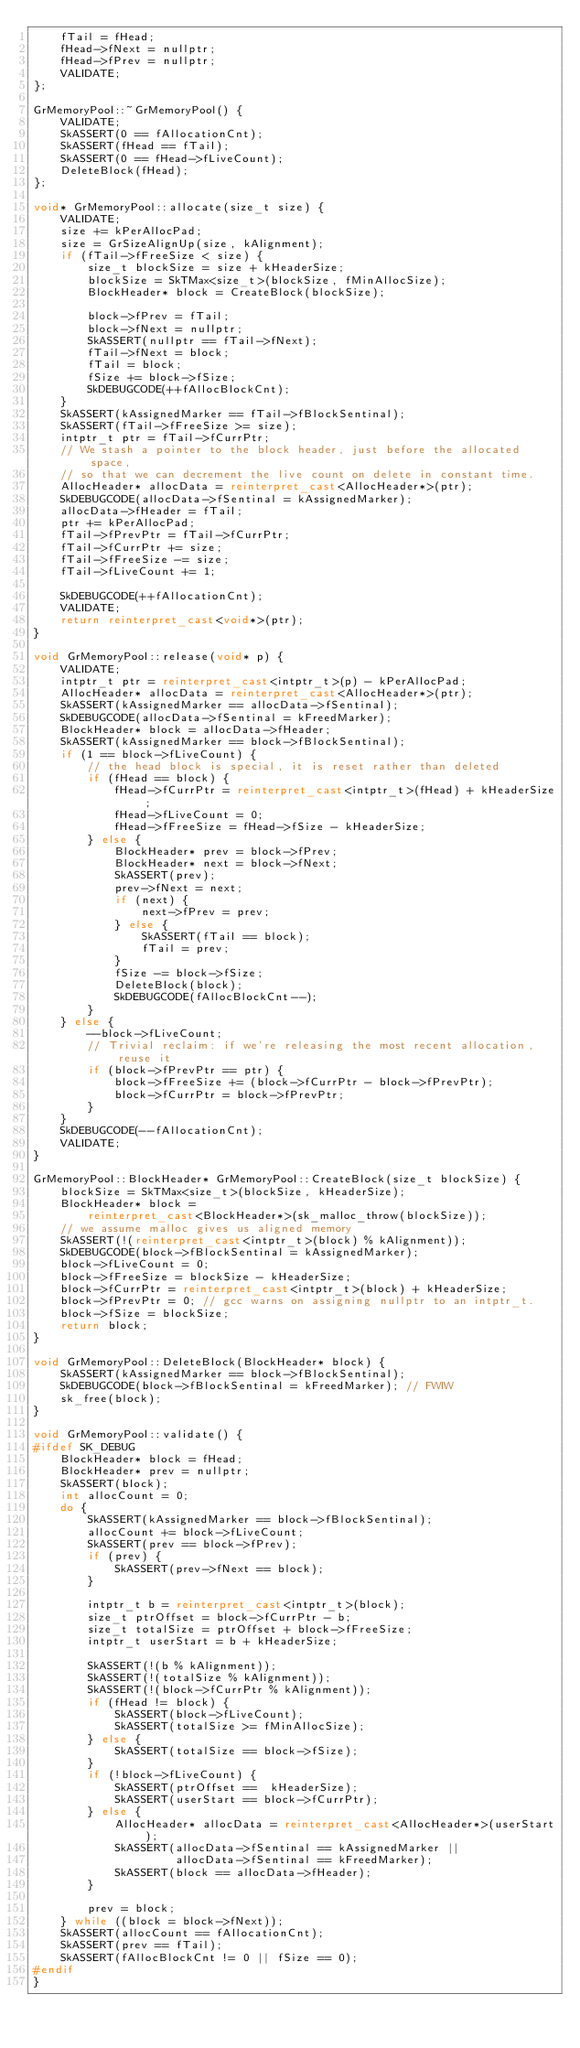Convert code to text. <code><loc_0><loc_0><loc_500><loc_500><_C++_>    fTail = fHead;
    fHead->fNext = nullptr;
    fHead->fPrev = nullptr;
    VALIDATE;
};

GrMemoryPool::~GrMemoryPool() {
    VALIDATE;
    SkASSERT(0 == fAllocationCnt);
    SkASSERT(fHead == fTail);
    SkASSERT(0 == fHead->fLiveCount);
    DeleteBlock(fHead);
};

void* GrMemoryPool::allocate(size_t size) {
    VALIDATE;
    size += kPerAllocPad;
    size = GrSizeAlignUp(size, kAlignment);
    if (fTail->fFreeSize < size) {
        size_t blockSize = size + kHeaderSize;
        blockSize = SkTMax<size_t>(blockSize, fMinAllocSize);
        BlockHeader* block = CreateBlock(blockSize);

        block->fPrev = fTail;
        block->fNext = nullptr;
        SkASSERT(nullptr == fTail->fNext);
        fTail->fNext = block;
        fTail = block;
        fSize += block->fSize;
        SkDEBUGCODE(++fAllocBlockCnt);
    }
    SkASSERT(kAssignedMarker == fTail->fBlockSentinal);
    SkASSERT(fTail->fFreeSize >= size);
    intptr_t ptr = fTail->fCurrPtr;
    // We stash a pointer to the block header, just before the allocated space,
    // so that we can decrement the live count on delete in constant time.
    AllocHeader* allocData = reinterpret_cast<AllocHeader*>(ptr);
    SkDEBUGCODE(allocData->fSentinal = kAssignedMarker);
    allocData->fHeader = fTail;
    ptr += kPerAllocPad;
    fTail->fPrevPtr = fTail->fCurrPtr;
    fTail->fCurrPtr += size;
    fTail->fFreeSize -= size;
    fTail->fLiveCount += 1;

    SkDEBUGCODE(++fAllocationCnt);
    VALIDATE;
    return reinterpret_cast<void*>(ptr);
}

void GrMemoryPool::release(void* p) {
    VALIDATE;
    intptr_t ptr = reinterpret_cast<intptr_t>(p) - kPerAllocPad;
    AllocHeader* allocData = reinterpret_cast<AllocHeader*>(ptr);
    SkASSERT(kAssignedMarker == allocData->fSentinal);
    SkDEBUGCODE(allocData->fSentinal = kFreedMarker);
    BlockHeader* block = allocData->fHeader;
    SkASSERT(kAssignedMarker == block->fBlockSentinal);
    if (1 == block->fLiveCount) {
        // the head block is special, it is reset rather than deleted
        if (fHead == block) {
            fHead->fCurrPtr = reinterpret_cast<intptr_t>(fHead) + kHeaderSize;
            fHead->fLiveCount = 0;
            fHead->fFreeSize = fHead->fSize - kHeaderSize;
        } else {
            BlockHeader* prev = block->fPrev;
            BlockHeader* next = block->fNext;
            SkASSERT(prev);
            prev->fNext = next;
            if (next) {
                next->fPrev = prev;
            } else {
                SkASSERT(fTail == block);
                fTail = prev;
            }
            fSize -= block->fSize;
            DeleteBlock(block);
            SkDEBUGCODE(fAllocBlockCnt--);
        }
    } else {
        --block->fLiveCount;
        // Trivial reclaim: if we're releasing the most recent allocation, reuse it
        if (block->fPrevPtr == ptr) {
            block->fFreeSize += (block->fCurrPtr - block->fPrevPtr);
            block->fCurrPtr = block->fPrevPtr;
        }
    }
    SkDEBUGCODE(--fAllocationCnt);
    VALIDATE;
}

GrMemoryPool::BlockHeader* GrMemoryPool::CreateBlock(size_t blockSize) {
    blockSize = SkTMax<size_t>(blockSize, kHeaderSize);
    BlockHeader* block =
        reinterpret_cast<BlockHeader*>(sk_malloc_throw(blockSize));
    // we assume malloc gives us aligned memory
    SkASSERT(!(reinterpret_cast<intptr_t>(block) % kAlignment));
    SkDEBUGCODE(block->fBlockSentinal = kAssignedMarker);
    block->fLiveCount = 0;
    block->fFreeSize = blockSize - kHeaderSize;
    block->fCurrPtr = reinterpret_cast<intptr_t>(block) + kHeaderSize;
    block->fPrevPtr = 0; // gcc warns on assigning nullptr to an intptr_t.
    block->fSize = blockSize;
    return block;
}

void GrMemoryPool::DeleteBlock(BlockHeader* block) {
    SkASSERT(kAssignedMarker == block->fBlockSentinal);
    SkDEBUGCODE(block->fBlockSentinal = kFreedMarker); // FWIW
    sk_free(block);
}

void GrMemoryPool::validate() {
#ifdef SK_DEBUG
    BlockHeader* block = fHead;
    BlockHeader* prev = nullptr;
    SkASSERT(block);
    int allocCount = 0;
    do {
        SkASSERT(kAssignedMarker == block->fBlockSentinal);
        allocCount += block->fLiveCount;
        SkASSERT(prev == block->fPrev);
        if (prev) {
            SkASSERT(prev->fNext == block);
        }

        intptr_t b = reinterpret_cast<intptr_t>(block);
        size_t ptrOffset = block->fCurrPtr - b;
        size_t totalSize = ptrOffset + block->fFreeSize;
        intptr_t userStart = b + kHeaderSize;

        SkASSERT(!(b % kAlignment));
        SkASSERT(!(totalSize % kAlignment));
        SkASSERT(!(block->fCurrPtr % kAlignment));
        if (fHead != block) {
            SkASSERT(block->fLiveCount);
            SkASSERT(totalSize >= fMinAllocSize);
        } else {
            SkASSERT(totalSize == block->fSize);
        }
        if (!block->fLiveCount) {
            SkASSERT(ptrOffset ==  kHeaderSize);
            SkASSERT(userStart == block->fCurrPtr);
        } else {
            AllocHeader* allocData = reinterpret_cast<AllocHeader*>(userStart);
            SkASSERT(allocData->fSentinal == kAssignedMarker ||
                     allocData->fSentinal == kFreedMarker);
            SkASSERT(block == allocData->fHeader);
        }

        prev = block;
    } while ((block = block->fNext));
    SkASSERT(allocCount == fAllocationCnt);
    SkASSERT(prev == fTail);
    SkASSERT(fAllocBlockCnt != 0 || fSize == 0);
#endif
}
</code> 